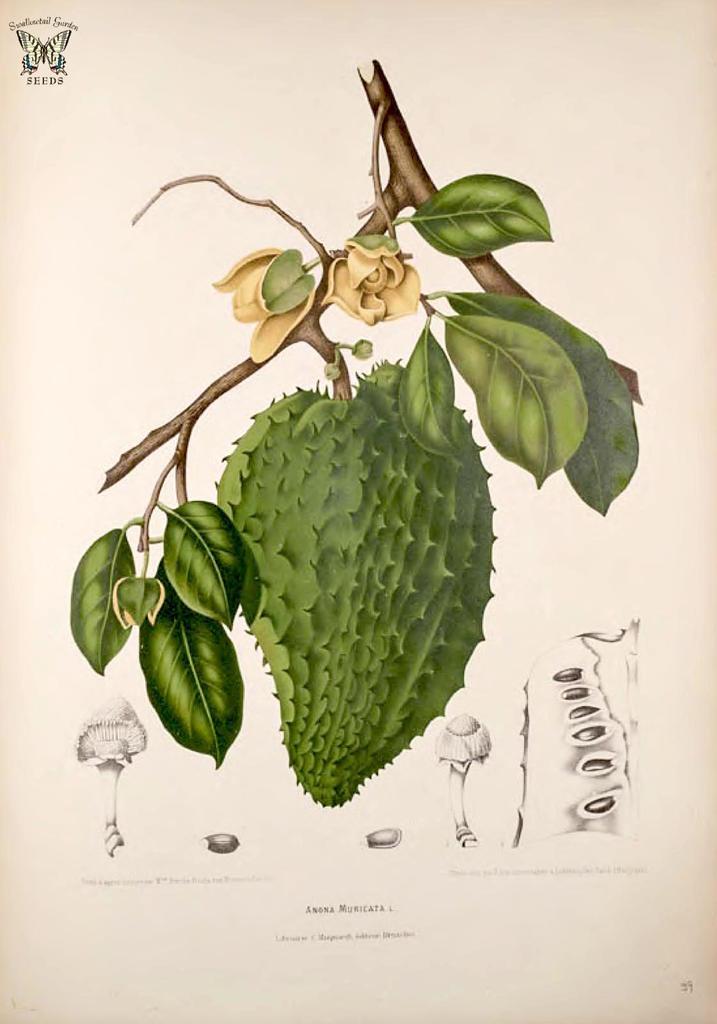Please provide a concise description of this image. This one is printed. This image consists of a fruit. There are leaves in this image. 